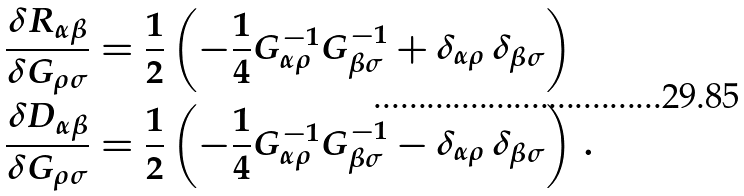<formula> <loc_0><loc_0><loc_500><loc_500>\frac { \delta R _ { \alpha \beta } } { \delta G _ { \rho \sigma } } & = \frac { 1 } { 2 } \left ( - \frac { 1 } { 4 } G _ { \alpha \rho } ^ { - 1 } G _ { \beta \sigma } ^ { - 1 } + \delta _ { \alpha \rho } \, \delta _ { \beta \sigma } \right ) \\ \frac { \delta D _ { \alpha \beta } } { \delta G _ { \rho \sigma } } & = \frac { 1 } { 2 } \left ( - \frac { 1 } { 4 } G _ { \alpha \rho } ^ { - 1 } G _ { \beta \sigma } ^ { - 1 } - \delta _ { \alpha \rho } \, \delta _ { \beta \sigma } \right ) \, .</formula> 